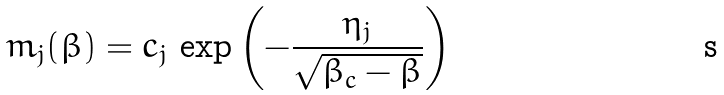<formula> <loc_0><loc_0><loc_500><loc_500>m _ { j } ( \beta ) = c _ { j } \, \exp \left ( - \frac { \eta _ { j } } { \sqrt { \beta _ { c } - \beta } } \right )</formula> 